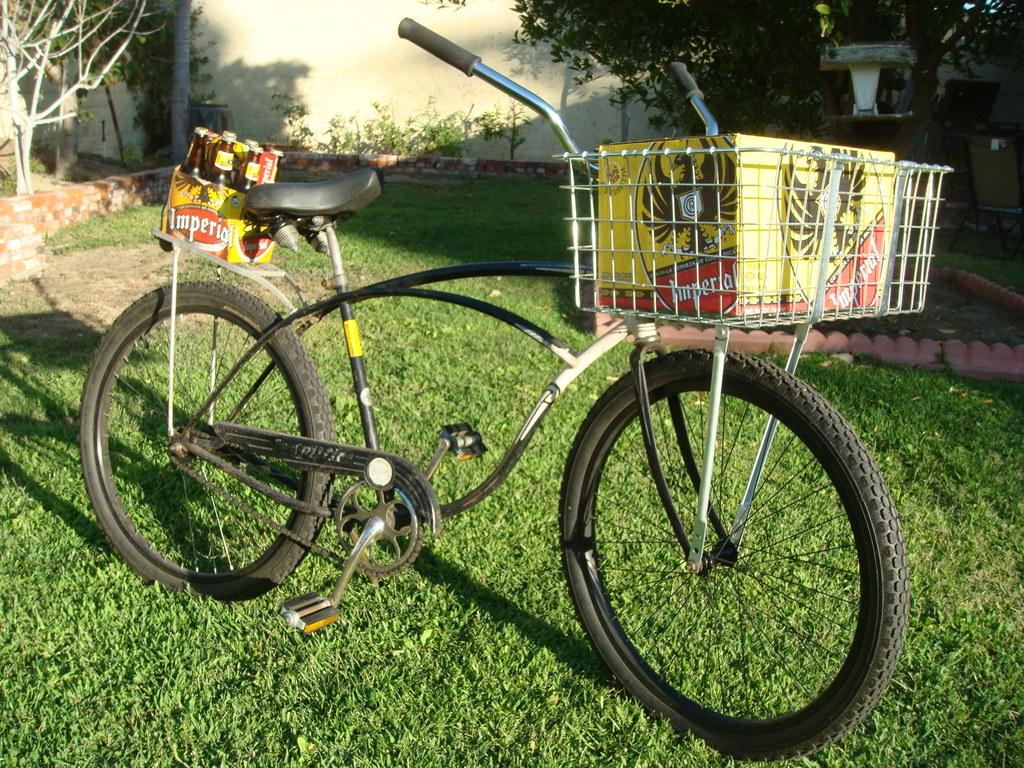What is the main object in the image? There is a bicycle in the image. What other items can be seen in the image? There are bottles, a box, grass, a plant, a wall, a pole, trees, and chairs in the image. Can you describe the setting of the image? The image features a grassy area with trees and a wall, and there are chairs and a box nearby. What might be used for holding or storing items in the image? The box and bottles in the image might be used for holding or storing items. What type of brass instrument is being played in the image? There is no brass instrument present in the image; it features a bicycle, bottles, a box, grass, a plant, a wall, a pole, trees, and chairs. 